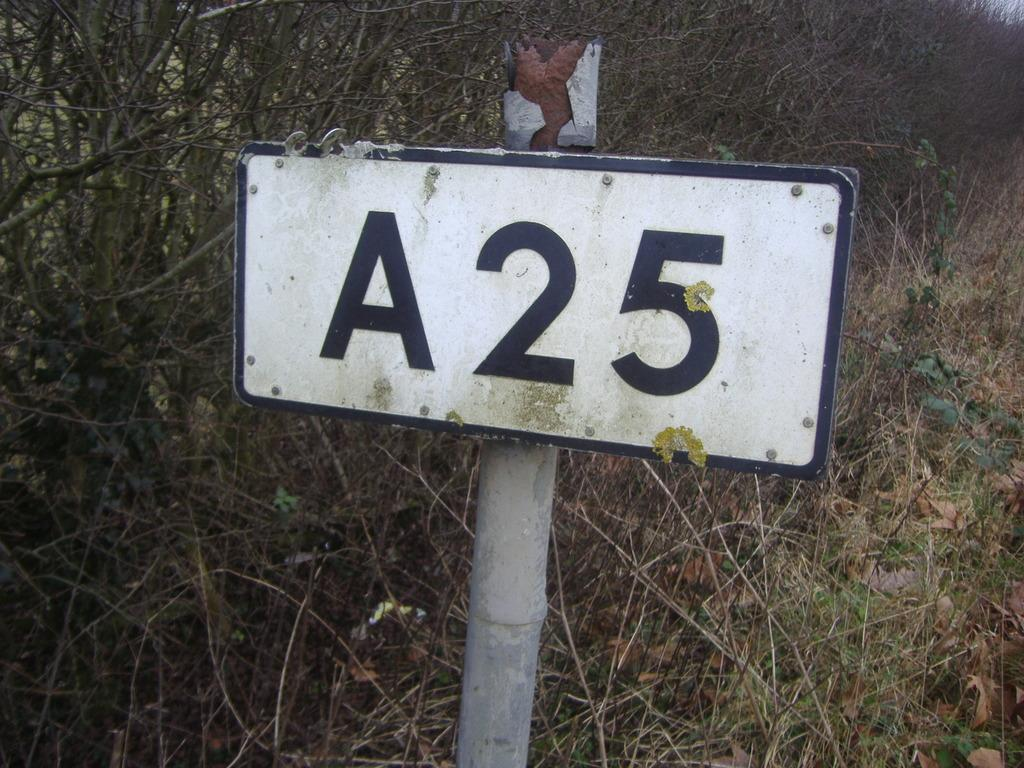<image>
Describe the image concisely. An old worn out sign on a rusted metal pole that reads A25. 